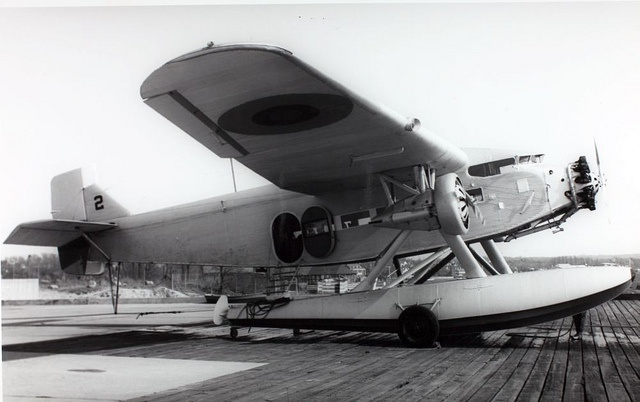Describe the objects in this image and their specific colors. I can see airplane in white, black, gray, darkgray, and lightgray tones and airplane in white, black, gray, lightgray, and darkgray tones in this image. 